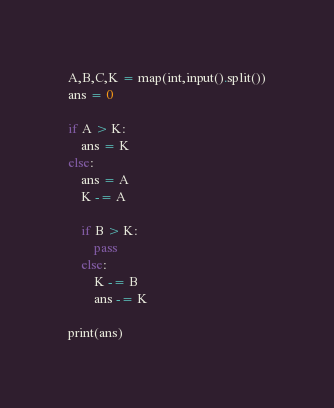Convert code to text. <code><loc_0><loc_0><loc_500><loc_500><_Python_>A,B,C,K = map(int,input().split())
ans = 0

if A > K:
    ans = K
else:
    ans = A
    K -= A
    
    if B > K:
        pass
    else:
        K -= B
        ans -= K
        
print(ans)</code> 